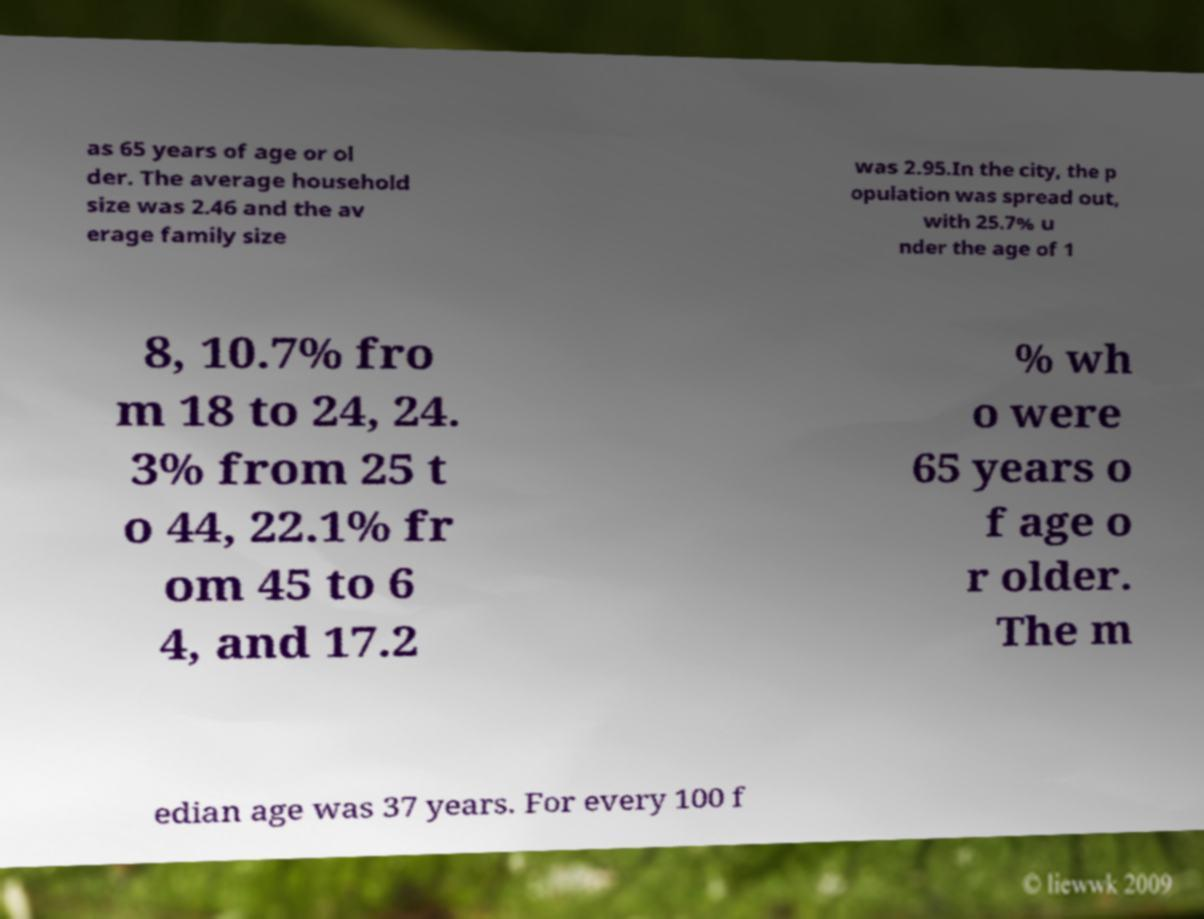I need the written content from this picture converted into text. Can you do that? as 65 years of age or ol der. The average household size was 2.46 and the av erage family size was 2.95.In the city, the p opulation was spread out, with 25.7% u nder the age of 1 8, 10.7% fro m 18 to 24, 24. 3% from 25 t o 44, 22.1% fr om 45 to 6 4, and 17.2 % wh o were 65 years o f age o r older. The m edian age was 37 years. For every 100 f 